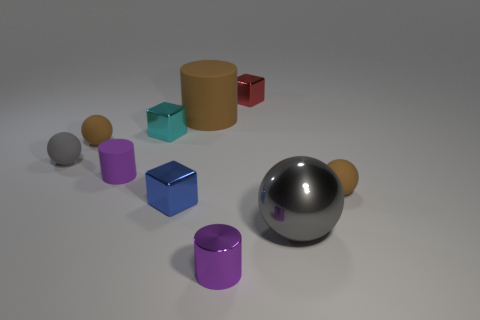Is the color of the small matte sphere that is on the right side of the big gray thing the same as the large thing in front of the small rubber cylinder?
Keep it short and to the point. No. How many metal objects are either large gray objects or big yellow cylinders?
Offer a terse response. 1. Is there anything else that is the same size as the gray metal sphere?
Provide a succinct answer. Yes. The big thing on the left side of the small metal block behind the big brown rubber object is what shape?
Your response must be concise. Cylinder. Do the tiny cube in front of the tiny gray matte sphere and the purple cylinder on the right side of the small blue thing have the same material?
Offer a very short reply. Yes. How many small cylinders are on the right side of the small brown rubber thing right of the metal cylinder?
Offer a very short reply. 0. Does the big object in front of the gray matte object have the same shape as the red object that is behind the large cylinder?
Give a very brief answer. No. There is a object that is both in front of the small gray matte thing and on the left side of the tiny blue shiny thing; what is its size?
Provide a succinct answer. Small. The tiny metallic thing that is the same shape as the big brown object is what color?
Ensure brevity in your answer.  Purple. There is a small cylinder behind the small brown object to the right of the small purple rubber cylinder; what color is it?
Make the answer very short. Purple. 